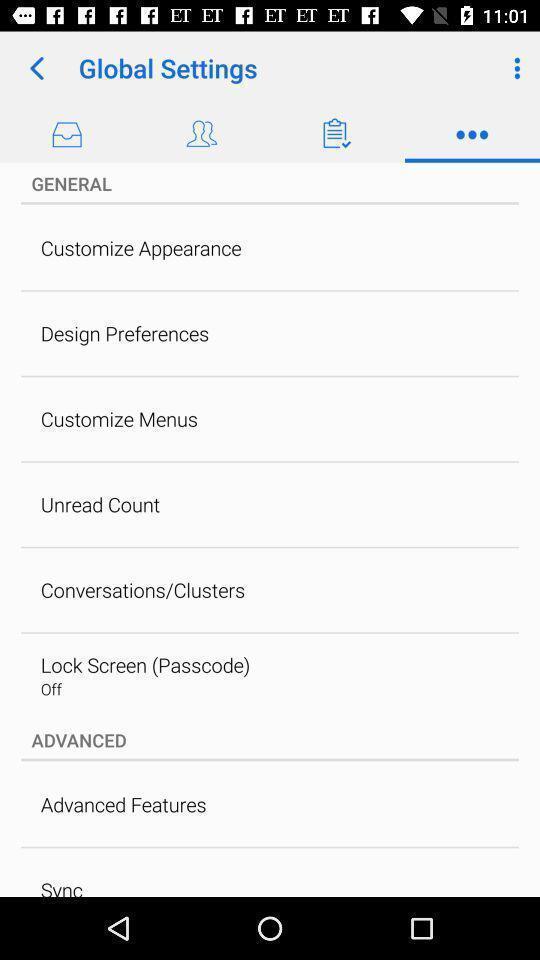Tell me about the visual elements in this screen capture. Settings page in a mailing app. 